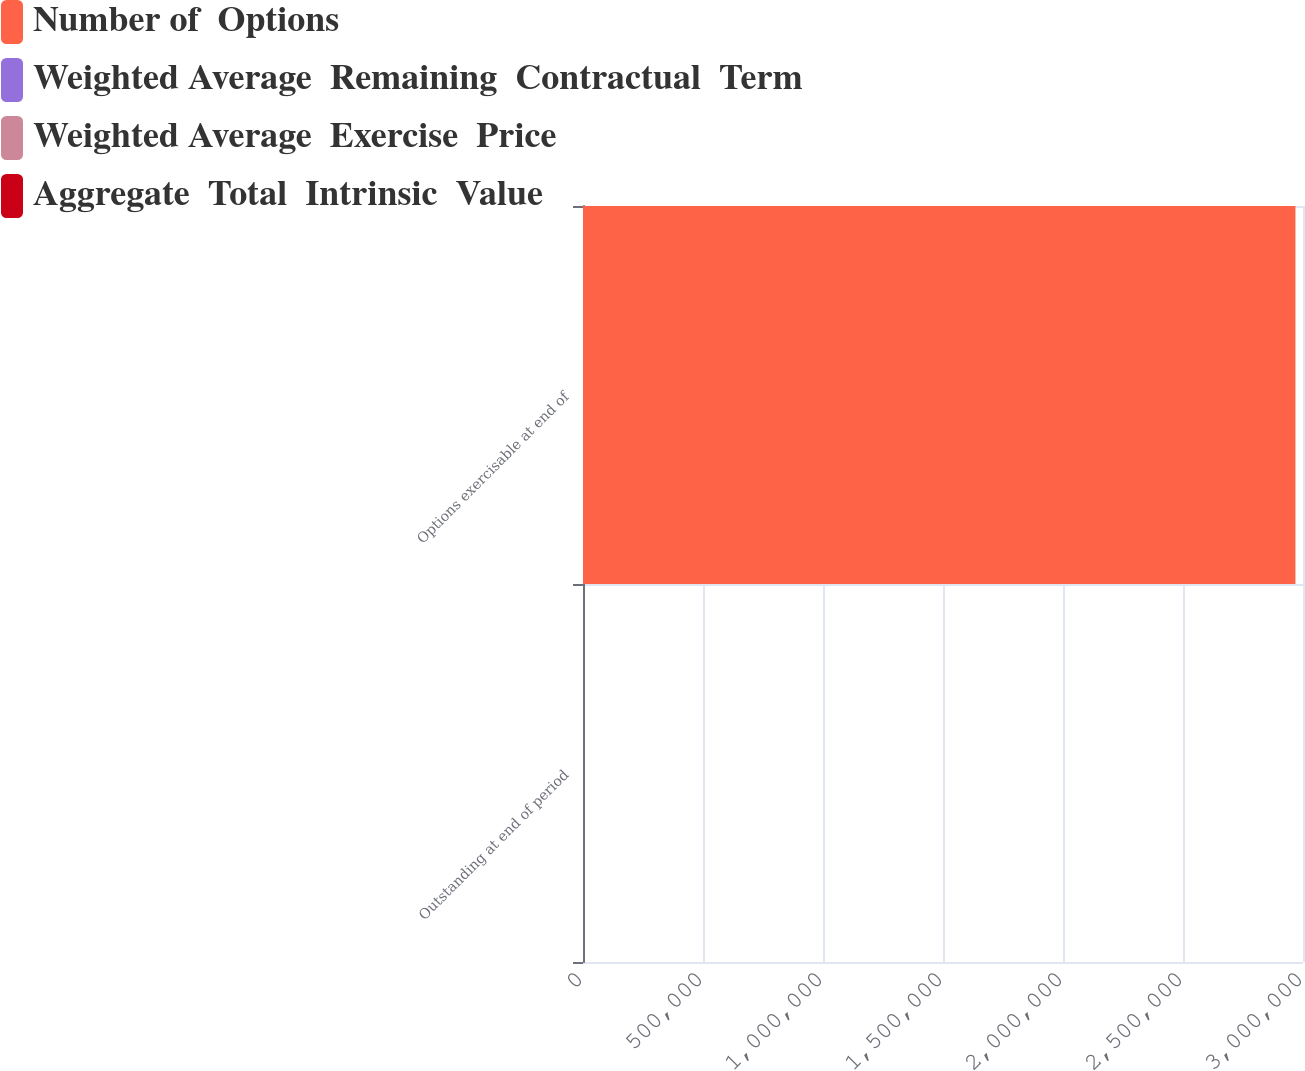<chart> <loc_0><loc_0><loc_500><loc_500><stacked_bar_chart><ecel><fcel>Outstanding at end of period<fcel>Options exercisable at end of<nl><fcel>Number of  Options<fcel>11<fcel>2.96855e+06<nl><fcel>Weighted Average  Remaining  Contractual  Term<fcel>32.59<fcel>30.73<nl><fcel>Weighted Average  Exercise  Price<fcel>6.8<fcel>5.8<nl><fcel>Aggregate  Total  Intrinsic  Value<fcel>11<fcel>11<nl></chart> 